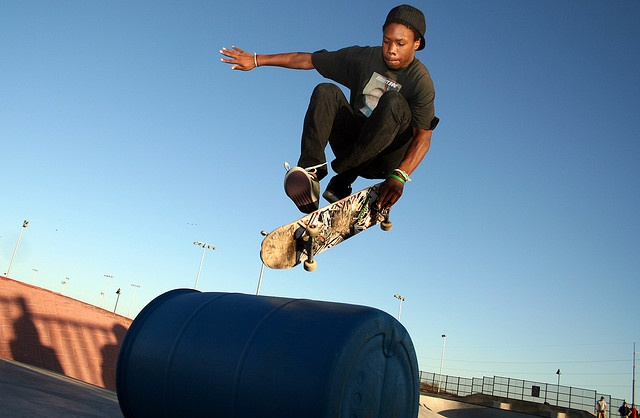Describe the objects in this image and their specific colors. I can see people in gray, black, maroon, and brown tones, skateboard in gray, black, tan, and khaki tones, people in gray, black, tan, and darkgray tones, people in gray, black, maroon, and brown tones, and people in gray, black, navy, olive, and maroon tones in this image. 